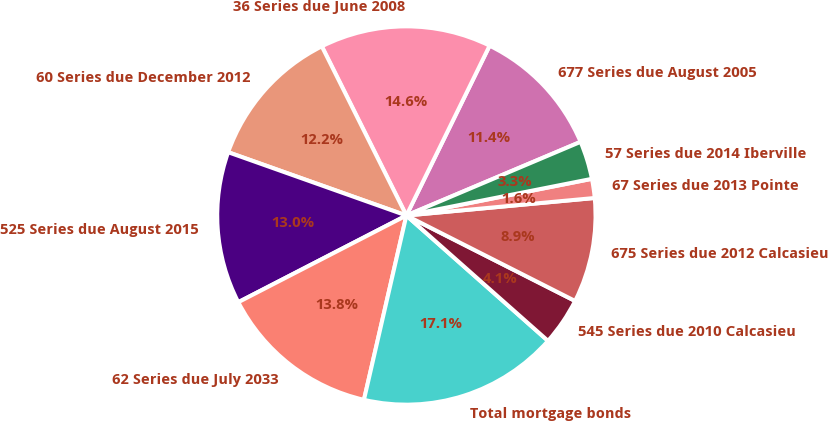Convert chart to OTSL. <chart><loc_0><loc_0><loc_500><loc_500><pie_chart><fcel>677 Series due August 2005<fcel>36 Series due June 2008<fcel>60 Series due December 2012<fcel>525 Series due August 2015<fcel>62 Series due July 2033<fcel>Total mortgage bonds<fcel>545 Series due 2010 Calcasieu<fcel>675 Series due 2012 Calcasieu<fcel>67 Series due 2013 Pointe<fcel>57 Series due 2014 Iberville<nl><fcel>11.38%<fcel>14.63%<fcel>12.19%<fcel>13.01%<fcel>13.82%<fcel>17.07%<fcel>4.07%<fcel>8.94%<fcel>1.63%<fcel>3.26%<nl></chart> 